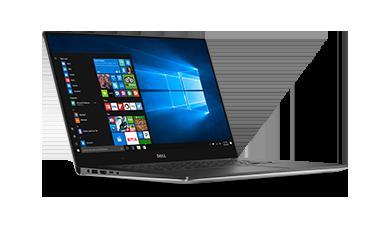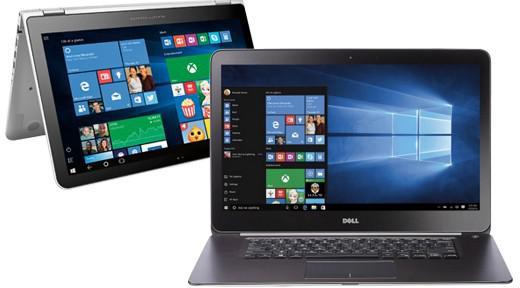The first image is the image on the left, the second image is the image on the right. Assess this claim about the two images: "The laptop in the image on the left is facing right.". Correct or not? Answer yes or no. Yes. 